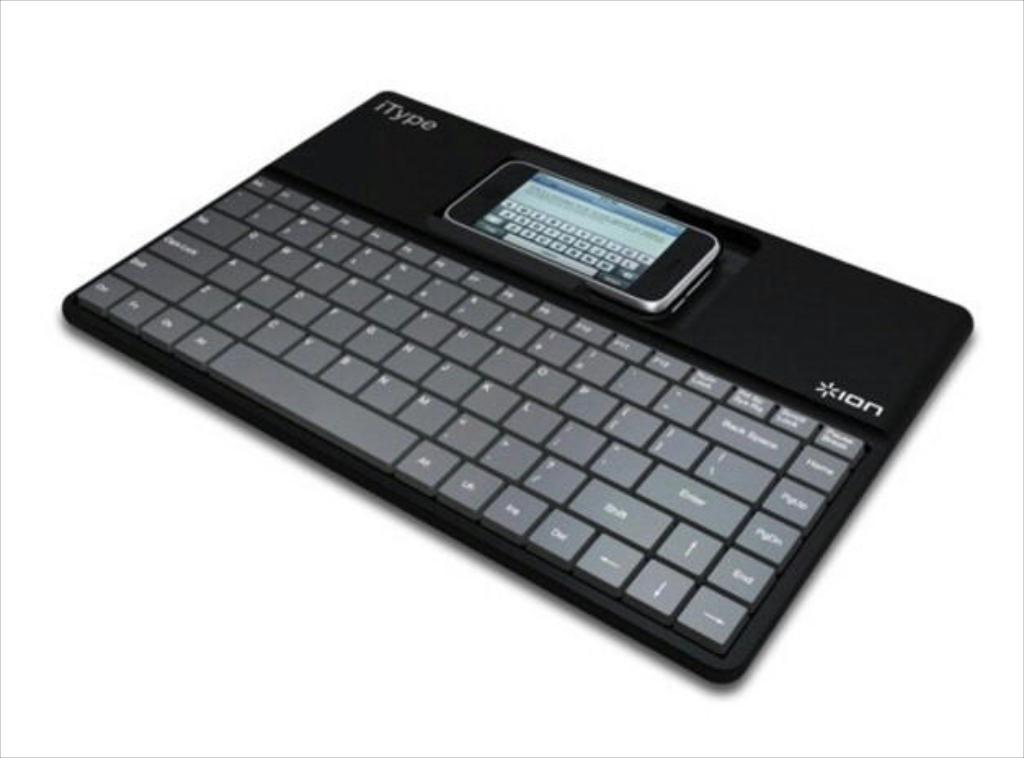<image>
Share a concise interpretation of the image provided. A cell phone sitting on top of a keyboard branded Ion. 